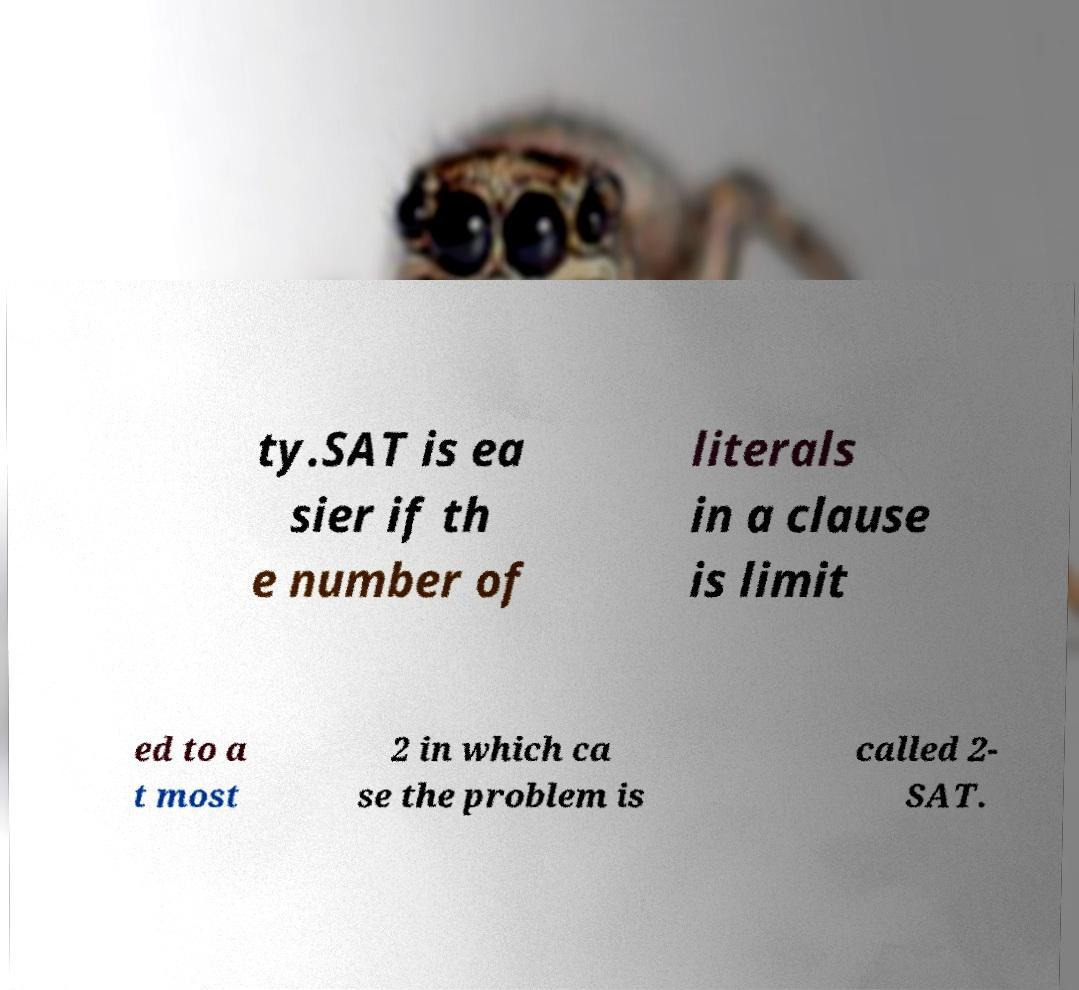For documentation purposes, I need the text within this image transcribed. Could you provide that? ty.SAT is ea sier if th e number of literals in a clause is limit ed to a t most 2 in which ca se the problem is called 2- SAT. 